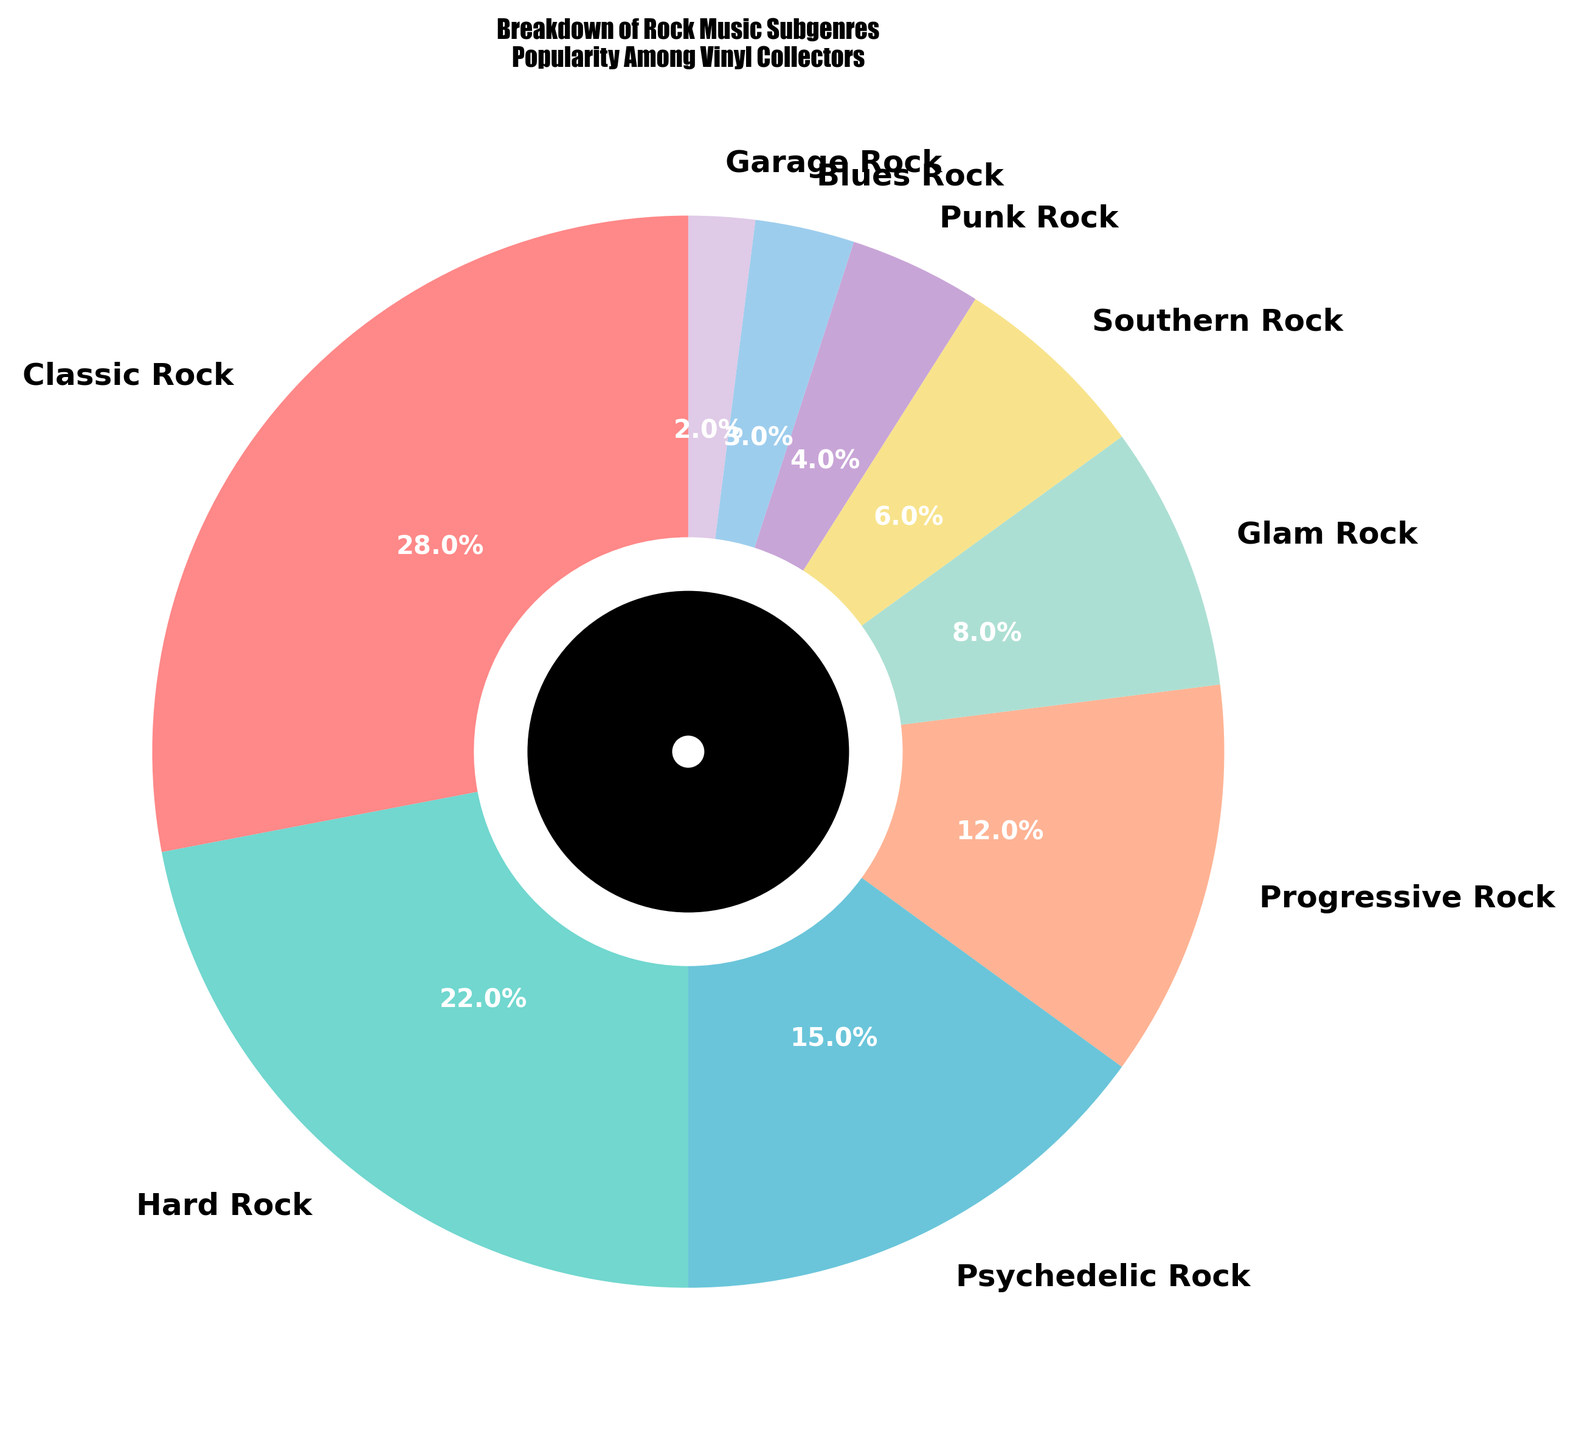Which subgenre has the highest popularity among vinyl collectors? The pie chart shows that Classic Rock has the largest slice of the pie, indicating it has the highest percentage.
Answer: Classic Rock Which subgenre is more popular, Psychedelic Rock or Hard Rock? By comparing the sizes of the slices, Psychedelic Rock has a 15% share while Hard Rock has a 22% share, making Hard Rock more popular.
Answer: Hard Rock How many subgenres have a popularity of less than 10%? The subgenres with less than 10% are Glam Rock (8%), Southern Rock (6%), Punk Rock (4%), Blues Rock (3%), and Garage Rock (2%). Counting these, there are 5 subgenres.
Answer: 5 What is the combined popularity percentage of Progressive Rock and Glam Rock? The percentage for Progressive Rock is 12% and for Glam Rock is 8%. Adding these gives 12% + 8% = 20%.
Answer: 20% Is Classic Rock more popular than the combined percentage of Punk Rock and Blues Rock? Classic Rock has 28%, while Punk Rock (4%) and Blues Rock (3%) add up to 7%. Since 28% > 7%, Classic Rock is more popular.
Answer: Yes Which subgenre has the smallest share in the pie chart? The smallest slice in the pie chart corresponds to Garage Rock with a 2% share.
Answer: Garage Rock What percentage of the chart is occupied by the top three subgenres? The top three subgenres are Classic Rock (28%), Hard Rock (22%), and Psychedelic Rock (15%). Summing these gives 28% + 22% + 15% = 65%.
Answer: 65% How does the popularity of Southern Rock compare to that of Blues Rock? Southern Rock has a 6% share, whereas Blues Rock has a 3% share. Since 6% > 3%, Southern Rock is more popular.
Answer: Southern Rock is more popular What is the difference in popularity between the largest and smallest subgenre? Classic Rock is the largest at 28% and Garage Rock is the smallest at 2%. The difference is 28% - 2% = 26%.
Answer: 26% What percentage of the pie chart do Progressive Rock, Glam Rock, and Southern Rock together occupy? Progressive Rock is 12%, Glam Rock is 8%, and Southern Rock is 6%. Adding these gives 12% + 8% + 6% = 26%.
Answer: 26% 